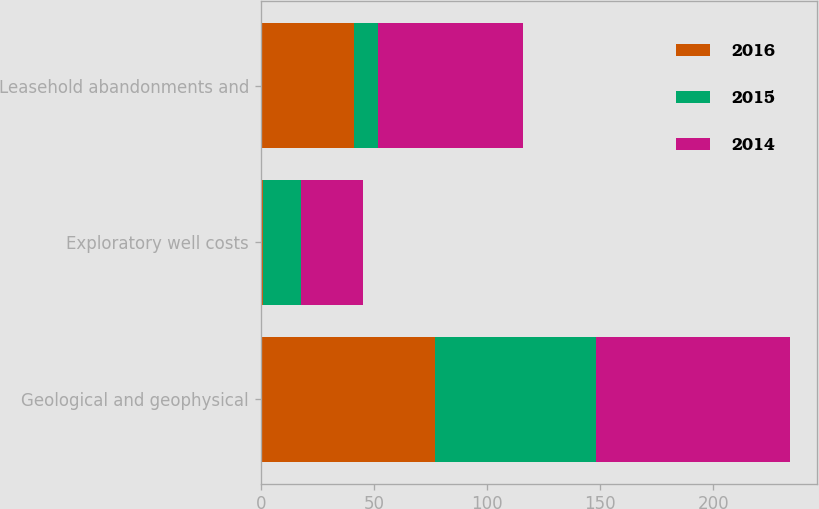Convert chart to OTSL. <chart><loc_0><loc_0><loc_500><loc_500><stacked_bar_chart><ecel><fcel>Geological and geophysical<fcel>Exploratory well costs<fcel>Leasehold abandonments and<nl><fcel>2016<fcel>77<fcel>1<fcel>41<nl><fcel>2015<fcel>71<fcel>17<fcel>11<nl><fcel>2014<fcel>86<fcel>27<fcel>64<nl></chart> 